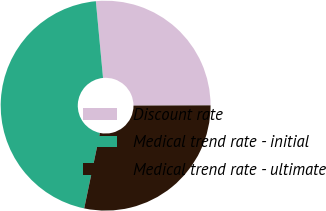Convert chart to OTSL. <chart><loc_0><loc_0><loc_500><loc_500><pie_chart><fcel>Discount rate<fcel>Medical trend rate - initial<fcel>Medical trend rate - ultimate<nl><fcel>26.44%<fcel>45.24%<fcel>28.32%<nl></chart> 